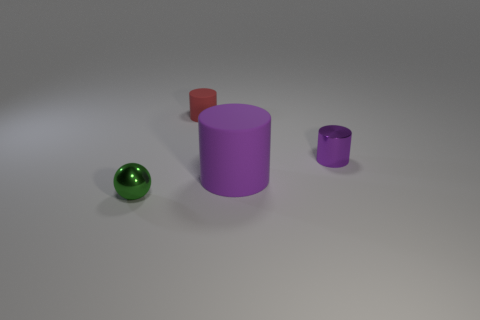Is there anything else that has the same size as the purple matte object?
Keep it short and to the point. No. Does the big cylinder have the same color as the small shiny cylinder?
Keep it short and to the point. Yes. There is a object that is the same color as the small shiny cylinder; what is it made of?
Offer a terse response. Rubber. Does the ball have the same size as the purple rubber cylinder?
Your response must be concise. No. There is a thing that is behind the small purple cylinder that is right of the red rubber cylinder; what size is it?
Make the answer very short. Small. Does the large object have the same color as the small metallic object that is right of the tiny green shiny thing?
Offer a very short reply. Yes. Are there any red rubber objects that have the same size as the green thing?
Make the answer very short. Yes. What size is the shiny object that is to the right of the small sphere?
Your response must be concise. Small. Are there any red rubber cylinders that are in front of the rubber cylinder in front of the metallic cylinder?
Make the answer very short. No. How many other things are the same shape as the red matte thing?
Your answer should be very brief. 2. 